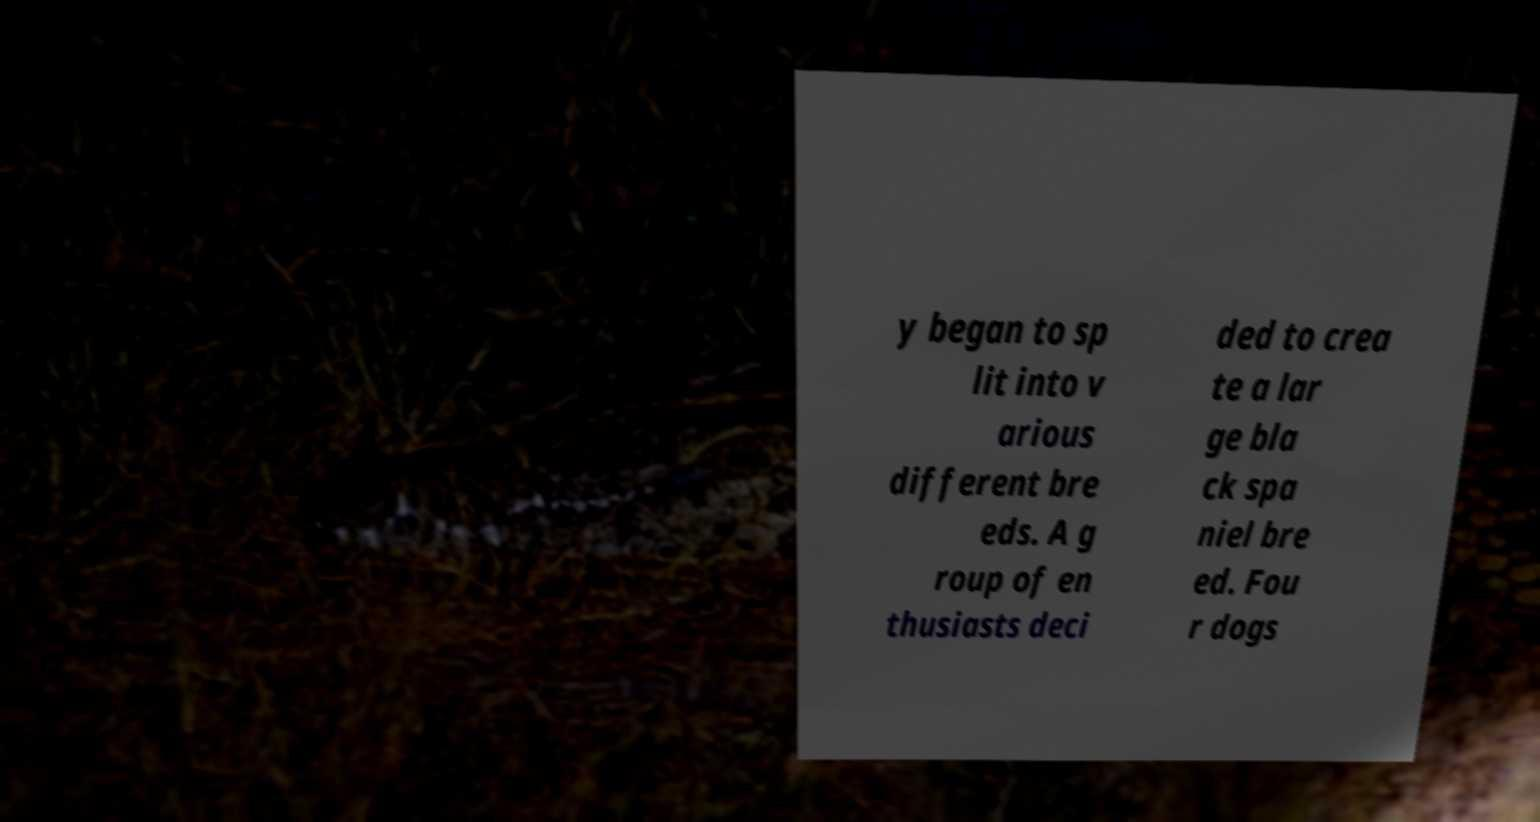For documentation purposes, I need the text within this image transcribed. Could you provide that? y began to sp lit into v arious different bre eds. A g roup of en thusiasts deci ded to crea te a lar ge bla ck spa niel bre ed. Fou r dogs 